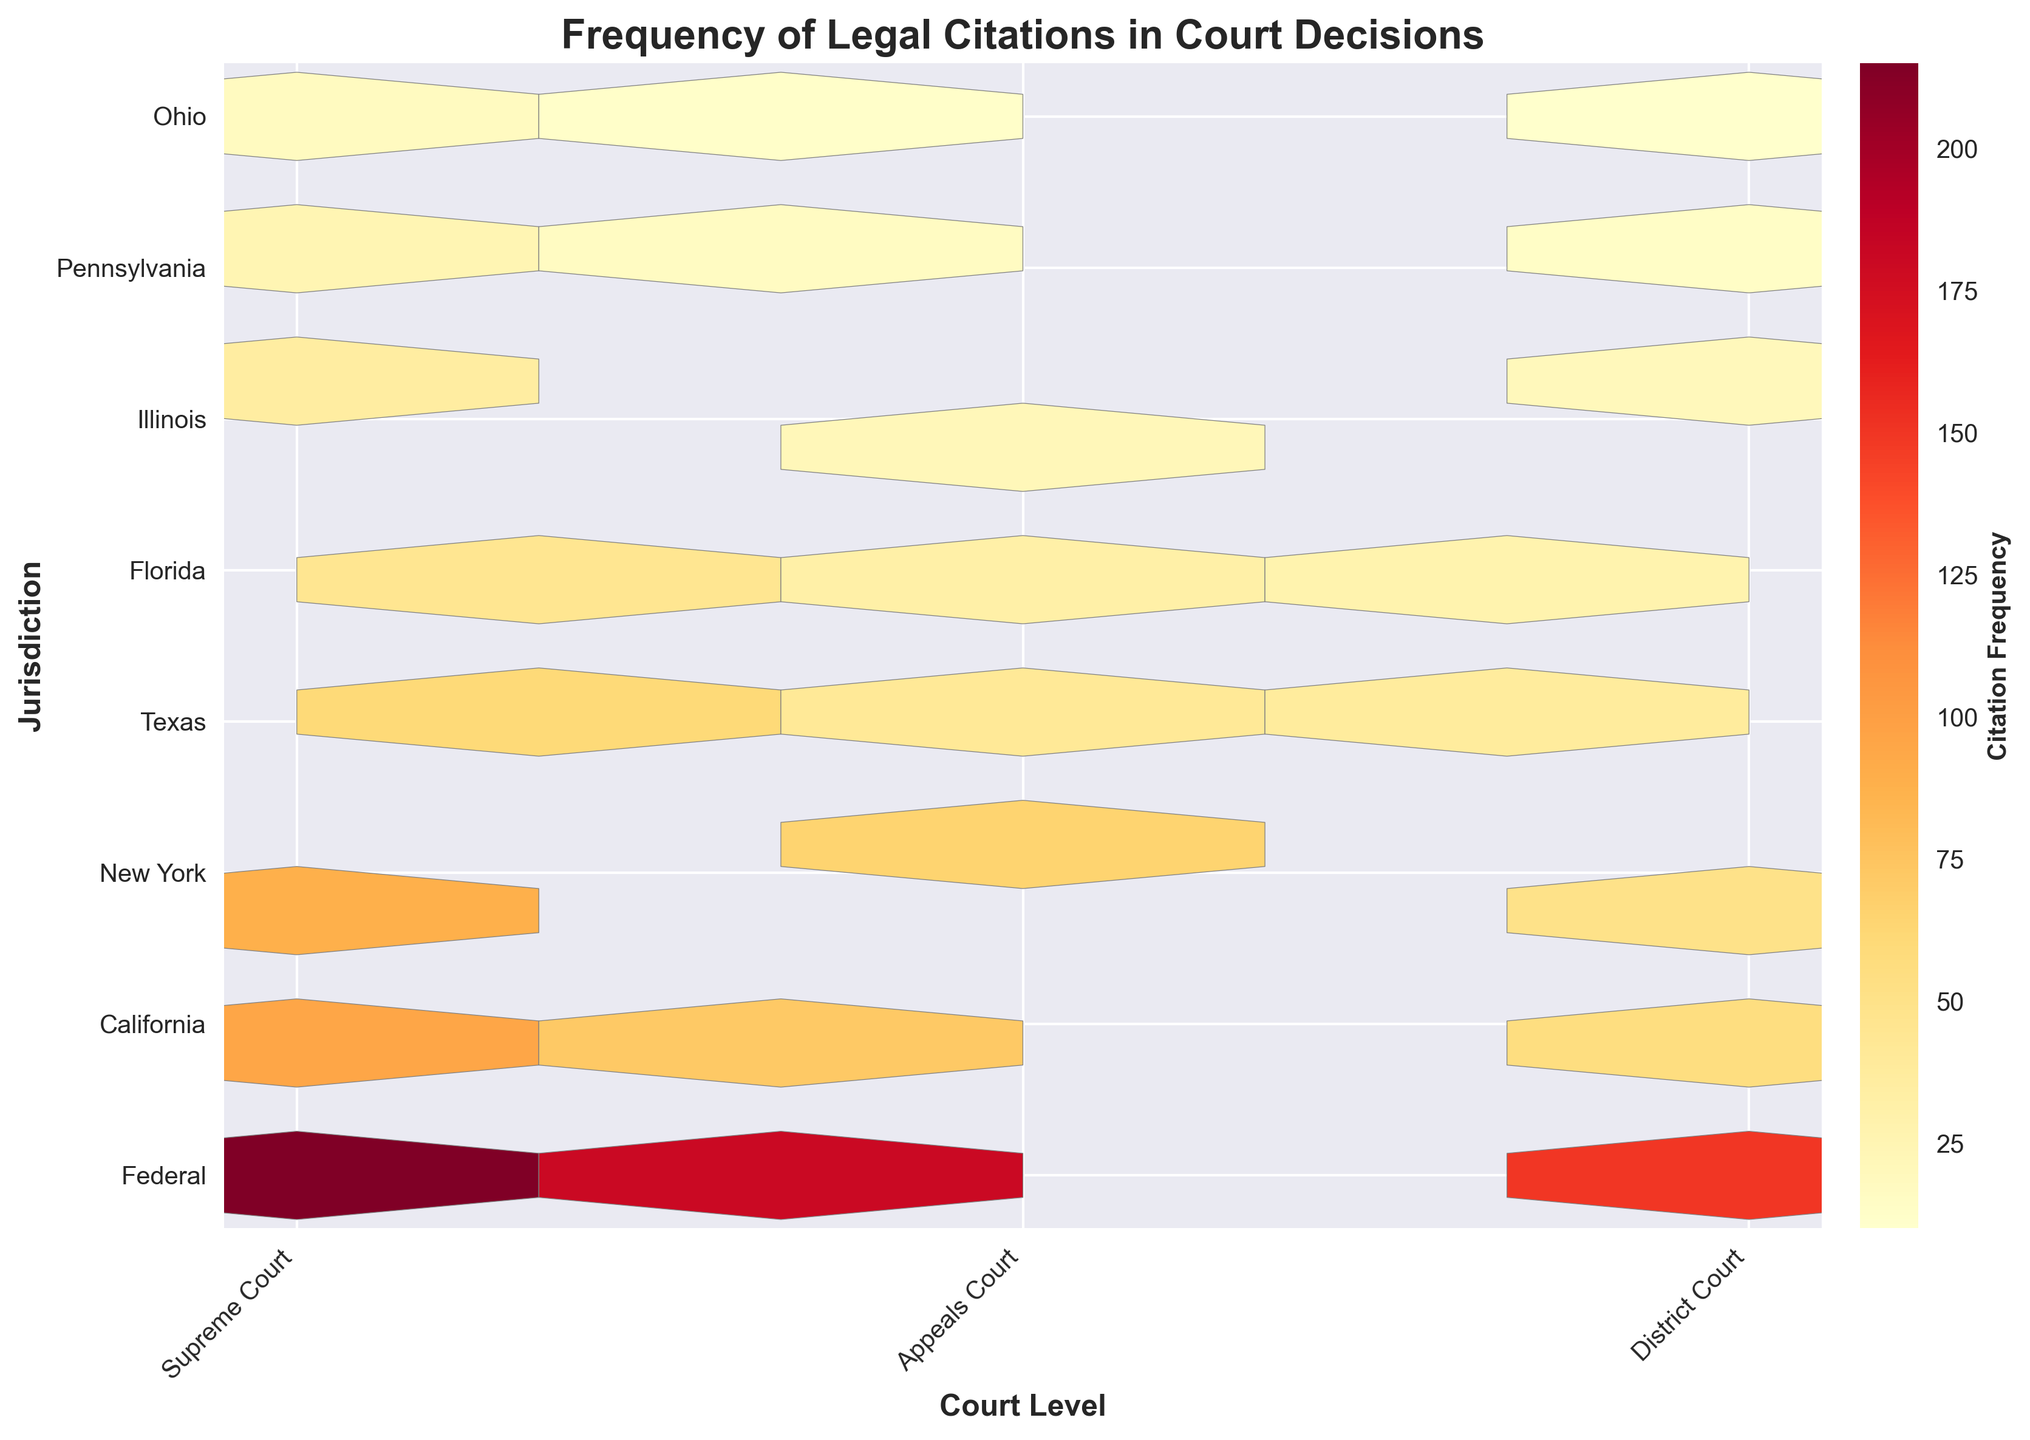What's the most frequently cited court and jurisdiction? By looking at the color intensity scale on the hexbin plot, the hexbin with the highest color intensity represents the most frequent citations. This corresponds to the intersection of 'Supreme Court' and 'Federal'.
Answer: Supreme Court, Federal What's the least frequently cited combination? By looking at the hexbin with the lightest color (indicating the least frequency), we find that the least frequent combination is 'District Court' and 'Ohio' due to the lowest color intensity.
Answer: District Court, Ohio How does citation frequency generally differ between the Supreme Court and District Court across all jurisdictions? By comparing the color intensities for Supreme Court and District Court across all jurisdictions, it’s evident that Supreme Court generally has a higher citation frequency compared to the District Court, as more of the hexagons are darker for the Supreme Court.
Answer: Supreme Court has a generally higher frequency than District Court Which jurisdiction is most frequently cited in Appeals Courts? By comparing the colors across the row representing Appeals Courts, the hexbin with the darkest color is found in the 'Federal' jurisdiction.
Answer: Federal What's the sum of citation frequencies for District Courts across all jurisdictions? To find this, sum the frequencies for 'District Court' across all jurisdictions: (150+55+50+38+28+20+14+10) = 365.
Answer: 365 Which court level has the highest average citation frequency across Federal and Ohio jurisdictions? Sum the frequencies for Supreme, Appeals, and District Courts in both Federal and Ohio, and calculate the average:
1. Supreme Court: (215 + 18) = 233
2. Appeals Court: (180 + 12) = 192
3. District Court: (150 + 10) = 160
Divide each by 2:
1. Supreme Court = 233 / 2 = 116.5
2. Appeals Court = 192 / 2 = 96
3. District Court = 160 / 2 = 80
The highest average is for the Supreme Court.
Answer: Supreme Court Which jurisdictions have more frequent citations in the Appeals Court compared to the District Court? Compare color intensities between Appeals Court and District Court within the same jurisdiction. Higher color intensities for Appeals Courts than District Courts are found in Federal, California, New York, and Texas.
Answer: Federal, California, New York, Texas 